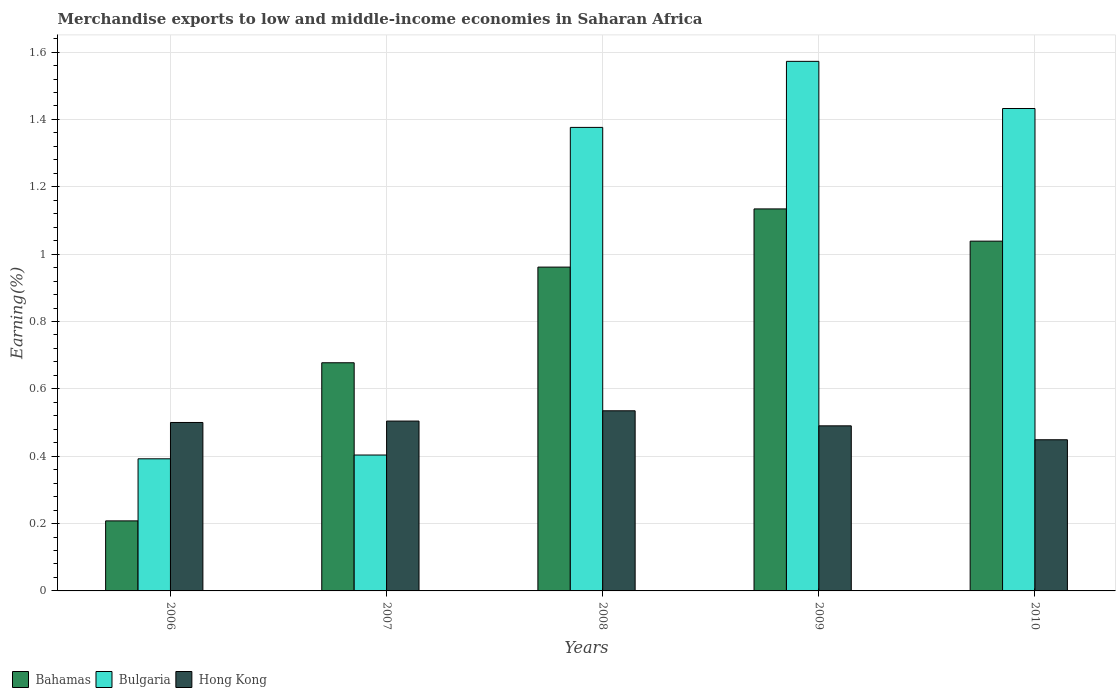Are the number of bars per tick equal to the number of legend labels?
Your answer should be very brief. Yes. Are the number of bars on each tick of the X-axis equal?
Your answer should be compact. Yes. What is the label of the 4th group of bars from the left?
Make the answer very short. 2009. What is the percentage of amount earned from merchandise exports in Hong Kong in 2008?
Keep it short and to the point. 0.53. Across all years, what is the maximum percentage of amount earned from merchandise exports in Hong Kong?
Your answer should be compact. 0.53. Across all years, what is the minimum percentage of amount earned from merchandise exports in Bulgaria?
Provide a short and direct response. 0.39. What is the total percentage of amount earned from merchandise exports in Bulgaria in the graph?
Offer a terse response. 5.18. What is the difference between the percentage of amount earned from merchandise exports in Bahamas in 2006 and that in 2009?
Keep it short and to the point. -0.93. What is the difference between the percentage of amount earned from merchandise exports in Hong Kong in 2007 and the percentage of amount earned from merchandise exports in Bulgaria in 2009?
Make the answer very short. -1.07. What is the average percentage of amount earned from merchandise exports in Bahamas per year?
Your answer should be very brief. 0.8. In the year 2008, what is the difference between the percentage of amount earned from merchandise exports in Bulgaria and percentage of amount earned from merchandise exports in Bahamas?
Keep it short and to the point. 0.41. In how many years, is the percentage of amount earned from merchandise exports in Bahamas greater than 0.56 %?
Your answer should be compact. 4. What is the ratio of the percentage of amount earned from merchandise exports in Bulgaria in 2007 to that in 2010?
Provide a succinct answer. 0.28. Is the difference between the percentage of amount earned from merchandise exports in Bulgaria in 2007 and 2008 greater than the difference between the percentage of amount earned from merchandise exports in Bahamas in 2007 and 2008?
Offer a terse response. No. What is the difference between the highest and the second highest percentage of amount earned from merchandise exports in Bahamas?
Offer a terse response. 0.1. What is the difference between the highest and the lowest percentage of amount earned from merchandise exports in Hong Kong?
Your response must be concise. 0.09. In how many years, is the percentage of amount earned from merchandise exports in Bahamas greater than the average percentage of amount earned from merchandise exports in Bahamas taken over all years?
Your response must be concise. 3. What does the 3rd bar from the left in 2008 represents?
Your response must be concise. Hong Kong. What does the 1st bar from the right in 2006 represents?
Provide a short and direct response. Hong Kong. How many bars are there?
Your response must be concise. 15. Are all the bars in the graph horizontal?
Keep it short and to the point. No. How many years are there in the graph?
Your response must be concise. 5. Are the values on the major ticks of Y-axis written in scientific E-notation?
Provide a short and direct response. No. Does the graph contain any zero values?
Provide a succinct answer. No. Where does the legend appear in the graph?
Ensure brevity in your answer.  Bottom left. How are the legend labels stacked?
Offer a terse response. Horizontal. What is the title of the graph?
Your answer should be compact. Merchandise exports to low and middle-income economies in Saharan Africa. Does "Tanzania" appear as one of the legend labels in the graph?
Provide a succinct answer. No. What is the label or title of the Y-axis?
Give a very brief answer. Earning(%). What is the Earning(%) of Bahamas in 2006?
Ensure brevity in your answer.  0.21. What is the Earning(%) of Bulgaria in 2006?
Ensure brevity in your answer.  0.39. What is the Earning(%) of Hong Kong in 2006?
Offer a very short reply. 0.5. What is the Earning(%) of Bahamas in 2007?
Your answer should be compact. 0.68. What is the Earning(%) of Bulgaria in 2007?
Provide a short and direct response. 0.4. What is the Earning(%) of Hong Kong in 2007?
Make the answer very short. 0.5. What is the Earning(%) in Bahamas in 2008?
Make the answer very short. 0.96. What is the Earning(%) in Bulgaria in 2008?
Your answer should be very brief. 1.38. What is the Earning(%) in Hong Kong in 2008?
Make the answer very short. 0.53. What is the Earning(%) of Bahamas in 2009?
Your answer should be very brief. 1.13. What is the Earning(%) of Bulgaria in 2009?
Offer a very short reply. 1.57. What is the Earning(%) of Hong Kong in 2009?
Your answer should be very brief. 0.49. What is the Earning(%) of Bahamas in 2010?
Provide a succinct answer. 1.04. What is the Earning(%) in Bulgaria in 2010?
Give a very brief answer. 1.43. What is the Earning(%) in Hong Kong in 2010?
Make the answer very short. 0.45. Across all years, what is the maximum Earning(%) in Bahamas?
Provide a succinct answer. 1.13. Across all years, what is the maximum Earning(%) of Bulgaria?
Your response must be concise. 1.57. Across all years, what is the maximum Earning(%) of Hong Kong?
Offer a very short reply. 0.53. Across all years, what is the minimum Earning(%) in Bahamas?
Your answer should be very brief. 0.21. Across all years, what is the minimum Earning(%) of Bulgaria?
Provide a short and direct response. 0.39. Across all years, what is the minimum Earning(%) in Hong Kong?
Your answer should be compact. 0.45. What is the total Earning(%) of Bahamas in the graph?
Offer a very short reply. 4.02. What is the total Earning(%) of Bulgaria in the graph?
Give a very brief answer. 5.18. What is the total Earning(%) in Hong Kong in the graph?
Provide a short and direct response. 2.48. What is the difference between the Earning(%) of Bahamas in 2006 and that in 2007?
Offer a terse response. -0.47. What is the difference between the Earning(%) of Bulgaria in 2006 and that in 2007?
Ensure brevity in your answer.  -0.01. What is the difference between the Earning(%) of Hong Kong in 2006 and that in 2007?
Give a very brief answer. -0. What is the difference between the Earning(%) of Bahamas in 2006 and that in 2008?
Your answer should be very brief. -0.75. What is the difference between the Earning(%) in Bulgaria in 2006 and that in 2008?
Provide a succinct answer. -0.98. What is the difference between the Earning(%) in Hong Kong in 2006 and that in 2008?
Offer a very short reply. -0.03. What is the difference between the Earning(%) in Bahamas in 2006 and that in 2009?
Give a very brief answer. -0.93. What is the difference between the Earning(%) of Bulgaria in 2006 and that in 2009?
Give a very brief answer. -1.18. What is the difference between the Earning(%) of Hong Kong in 2006 and that in 2009?
Your response must be concise. 0.01. What is the difference between the Earning(%) of Bahamas in 2006 and that in 2010?
Offer a very short reply. -0.83. What is the difference between the Earning(%) of Bulgaria in 2006 and that in 2010?
Your answer should be very brief. -1.04. What is the difference between the Earning(%) in Hong Kong in 2006 and that in 2010?
Make the answer very short. 0.05. What is the difference between the Earning(%) of Bahamas in 2007 and that in 2008?
Your response must be concise. -0.28. What is the difference between the Earning(%) of Bulgaria in 2007 and that in 2008?
Keep it short and to the point. -0.97. What is the difference between the Earning(%) of Hong Kong in 2007 and that in 2008?
Provide a succinct answer. -0.03. What is the difference between the Earning(%) in Bahamas in 2007 and that in 2009?
Ensure brevity in your answer.  -0.46. What is the difference between the Earning(%) of Bulgaria in 2007 and that in 2009?
Give a very brief answer. -1.17. What is the difference between the Earning(%) in Hong Kong in 2007 and that in 2009?
Give a very brief answer. 0.01. What is the difference between the Earning(%) in Bahamas in 2007 and that in 2010?
Ensure brevity in your answer.  -0.36. What is the difference between the Earning(%) of Bulgaria in 2007 and that in 2010?
Your answer should be compact. -1.03. What is the difference between the Earning(%) of Hong Kong in 2007 and that in 2010?
Your answer should be very brief. 0.06. What is the difference between the Earning(%) in Bahamas in 2008 and that in 2009?
Provide a short and direct response. -0.17. What is the difference between the Earning(%) in Bulgaria in 2008 and that in 2009?
Provide a short and direct response. -0.2. What is the difference between the Earning(%) in Hong Kong in 2008 and that in 2009?
Offer a terse response. 0.04. What is the difference between the Earning(%) in Bahamas in 2008 and that in 2010?
Your response must be concise. -0.08. What is the difference between the Earning(%) of Bulgaria in 2008 and that in 2010?
Keep it short and to the point. -0.06. What is the difference between the Earning(%) in Hong Kong in 2008 and that in 2010?
Your answer should be very brief. 0.09. What is the difference between the Earning(%) in Bahamas in 2009 and that in 2010?
Give a very brief answer. 0.1. What is the difference between the Earning(%) of Bulgaria in 2009 and that in 2010?
Keep it short and to the point. 0.14. What is the difference between the Earning(%) in Hong Kong in 2009 and that in 2010?
Make the answer very short. 0.04. What is the difference between the Earning(%) of Bahamas in 2006 and the Earning(%) of Bulgaria in 2007?
Give a very brief answer. -0.2. What is the difference between the Earning(%) of Bahamas in 2006 and the Earning(%) of Hong Kong in 2007?
Give a very brief answer. -0.3. What is the difference between the Earning(%) of Bulgaria in 2006 and the Earning(%) of Hong Kong in 2007?
Your answer should be very brief. -0.11. What is the difference between the Earning(%) of Bahamas in 2006 and the Earning(%) of Bulgaria in 2008?
Your answer should be compact. -1.17. What is the difference between the Earning(%) in Bahamas in 2006 and the Earning(%) in Hong Kong in 2008?
Offer a very short reply. -0.33. What is the difference between the Earning(%) of Bulgaria in 2006 and the Earning(%) of Hong Kong in 2008?
Your response must be concise. -0.14. What is the difference between the Earning(%) in Bahamas in 2006 and the Earning(%) in Bulgaria in 2009?
Give a very brief answer. -1.36. What is the difference between the Earning(%) of Bahamas in 2006 and the Earning(%) of Hong Kong in 2009?
Your answer should be very brief. -0.28. What is the difference between the Earning(%) in Bulgaria in 2006 and the Earning(%) in Hong Kong in 2009?
Your answer should be compact. -0.1. What is the difference between the Earning(%) in Bahamas in 2006 and the Earning(%) in Bulgaria in 2010?
Your answer should be very brief. -1.22. What is the difference between the Earning(%) of Bahamas in 2006 and the Earning(%) of Hong Kong in 2010?
Ensure brevity in your answer.  -0.24. What is the difference between the Earning(%) of Bulgaria in 2006 and the Earning(%) of Hong Kong in 2010?
Ensure brevity in your answer.  -0.06. What is the difference between the Earning(%) of Bahamas in 2007 and the Earning(%) of Bulgaria in 2008?
Your answer should be compact. -0.7. What is the difference between the Earning(%) in Bahamas in 2007 and the Earning(%) in Hong Kong in 2008?
Offer a very short reply. 0.14. What is the difference between the Earning(%) in Bulgaria in 2007 and the Earning(%) in Hong Kong in 2008?
Offer a terse response. -0.13. What is the difference between the Earning(%) of Bahamas in 2007 and the Earning(%) of Bulgaria in 2009?
Give a very brief answer. -0.9. What is the difference between the Earning(%) of Bahamas in 2007 and the Earning(%) of Hong Kong in 2009?
Your answer should be very brief. 0.19. What is the difference between the Earning(%) in Bulgaria in 2007 and the Earning(%) in Hong Kong in 2009?
Keep it short and to the point. -0.09. What is the difference between the Earning(%) in Bahamas in 2007 and the Earning(%) in Bulgaria in 2010?
Provide a succinct answer. -0.76. What is the difference between the Earning(%) in Bahamas in 2007 and the Earning(%) in Hong Kong in 2010?
Ensure brevity in your answer.  0.23. What is the difference between the Earning(%) of Bulgaria in 2007 and the Earning(%) of Hong Kong in 2010?
Your answer should be compact. -0.05. What is the difference between the Earning(%) in Bahamas in 2008 and the Earning(%) in Bulgaria in 2009?
Provide a short and direct response. -0.61. What is the difference between the Earning(%) in Bahamas in 2008 and the Earning(%) in Hong Kong in 2009?
Provide a succinct answer. 0.47. What is the difference between the Earning(%) in Bulgaria in 2008 and the Earning(%) in Hong Kong in 2009?
Keep it short and to the point. 0.89. What is the difference between the Earning(%) in Bahamas in 2008 and the Earning(%) in Bulgaria in 2010?
Your answer should be compact. -0.47. What is the difference between the Earning(%) in Bahamas in 2008 and the Earning(%) in Hong Kong in 2010?
Keep it short and to the point. 0.51. What is the difference between the Earning(%) in Bulgaria in 2008 and the Earning(%) in Hong Kong in 2010?
Provide a short and direct response. 0.93. What is the difference between the Earning(%) in Bahamas in 2009 and the Earning(%) in Bulgaria in 2010?
Ensure brevity in your answer.  -0.3. What is the difference between the Earning(%) in Bahamas in 2009 and the Earning(%) in Hong Kong in 2010?
Keep it short and to the point. 0.69. What is the difference between the Earning(%) of Bulgaria in 2009 and the Earning(%) of Hong Kong in 2010?
Give a very brief answer. 1.12. What is the average Earning(%) of Bahamas per year?
Your response must be concise. 0.8. What is the average Earning(%) of Bulgaria per year?
Offer a very short reply. 1.04. What is the average Earning(%) in Hong Kong per year?
Ensure brevity in your answer.  0.5. In the year 2006, what is the difference between the Earning(%) of Bahamas and Earning(%) of Bulgaria?
Provide a succinct answer. -0.18. In the year 2006, what is the difference between the Earning(%) in Bahamas and Earning(%) in Hong Kong?
Keep it short and to the point. -0.29. In the year 2006, what is the difference between the Earning(%) in Bulgaria and Earning(%) in Hong Kong?
Your answer should be compact. -0.11. In the year 2007, what is the difference between the Earning(%) in Bahamas and Earning(%) in Bulgaria?
Keep it short and to the point. 0.27. In the year 2007, what is the difference between the Earning(%) in Bahamas and Earning(%) in Hong Kong?
Your answer should be compact. 0.17. In the year 2007, what is the difference between the Earning(%) of Bulgaria and Earning(%) of Hong Kong?
Your answer should be compact. -0.1. In the year 2008, what is the difference between the Earning(%) in Bahamas and Earning(%) in Bulgaria?
Offer a terse response. -0.41. In the year 2008, what is the difference between the Earning(%) in Bahamas and Earning(%) in Hong Kong?
Ensure brevity in your answer.  0.43. In the year 2008, what is the difference between the Earning(%) in Bulgaria and Earning(%) in Hong Kong?
Your response must be concise. 0.84. In the year 2009, what is the difference between the Earning(%) in Bahamas and Earning(%) in Bulgaria?
Ensure brevity in your answer.  -0.44. In the year 2009, what is the difference between the Earning(%) of Bahamas and Earning(%) of Hong Kong?
Give a very brief answer. 0.64. In the year 2009, what is the difference between the Earning(%) of Bulgaria and Earning(%) of Hong Kong?
Offer a very short reply. 1.08. In the year 2010, what is the difference between the Earning(%) in Bahamas and Earning(%) in Bulgaria?
Your response must be concise. -0.39. In the year 2010, what is the difference between the Earning(%) in Bahamas and Earning(%) in Hong Kong?
Provide a short and direct response. 0.59. In the year 2010, what is the difference between the Earning(%) in Bulgaria and Earning(%) in Hong Kong?
Ensure brevity in your answer.  0.98. What is the ratio of the Earning(%) of Bahamas in 2006 to that in 2007?
Make the answer very short. 0.31. What is the ratio of the Earning(%) of Bulgaria in 2006 to that in 2007?
Your answer should be very brief. 0.97. What is the ratio of the Earning(%) of Bahamas in 2006 to that in 2008?
Offer a very short reply. 0.22. What is the ratio of the Earning(%) in Bulgaria in 2006 to that in 2008?
Keep it short and to the point. 0.28. What is the ratio of the Earning(%) in Hong Kong in 2006 to that in 2008?
Your answer should be compact. 0.94. What is the ratio of the Earning(%) of Bahamas in 2006 to that in 2009?
Offer a very short reply. 0.18. What is the ratio of the Earning(%) of Bulgaria in 2006 to that in 2009?
Offer a terse response. 0.25. What is the ratio of the Earning(%) of Hong Kong in 2006 to that in 2009?
Provide a succinct answer. 1.02. What is the ratio of the Earning(%) of Bahamas in 2006 to that in 2010?
Provide a succinct answer. 0.2. What is the ratio of the Earning(%) of Bulgaria in 2006 to that in 2010?
Provide a short and direct response. 0.27. What is the ratio of the Earning(%) in Hong Kong in 2006 to that in 2010?
Provide a short and direct response. 1.11. What is the ratio of the Earning(%) of Bahamas in 2007 to that in 2008?
Your answer should be very brief. 0.7. What is the ratio of the Earning(%) in Bulgaria in 2007 to that in 2008?
Ensure brevity in your answer.  0.29. What is the ratio of the Earning(%) of Hong Kong in 2007 to that in 2008?
Your answer should be compact. 0.94. What is the ratio of the Earning(%) of Bahamas in 2007 to that in 2009?
Your response must be concise. 0.6. What is the ratio of the Earning(%) in Bulgaria in 2007 to that in 2009?
Make the answer very short. 0.26. What is the ratio of the Earning(%) in Hong Kong in 2007 to that in 2009?
Your answer should be compact. 1.03. What is the ratio of the Earning(%) of Bahamas in 2007 to that in 2010?
Ensure brevity in your answer.  0.65. What is the ratio of the Earning(%) of Bulgaria in 2007 to that in 2010?
Your response must be concise. 0.28. What is the ratio of the Earning(%) in Hong Kong in 2007 to that in 2010?
Give a very brief answer. 1.12. What is the ratio of the Earning(%) of Bahamas in 2008 to that in 2009?
Your response must be concise. 0.85. What is the ratio of the Earning(%) in Bulgaria in 2008 to that in 2009?
Provide a short and direct response. 0.88. What is the ratio of the Earning(%) in Hong Kong in 2008 to that in 2009?
Offer a terse response. 1.09. What is the ratio of the Earning(%) of Bahamas in 2008 to that in 2010?
Make the answer very short. 0.93. What is the ratio of the Earning(%) of Bulgaria in 2008 to that in 2010?
Keep it short and to the point. 0.96. What is the ratio of the Earning(%) of Hong Kong in 2008 to that in 2010?
Make the answer very short. 1.19. What is the ratio of the Earning(%) in Bahamas in 2009 to that in 2010?
Provide a short and direct response. 1.09. What is the ratio of the Earning(%) in Bulgaria in 2009 to that in 2010?
Offer a terse response. 1.1. What is the ratio of the Earning(%) in Hong Kong in 2009 to that in 2010?
Provide a short and direct response. 1.09. What is the difference between the highest and the second highest Earning(%) in Bahamas?
Offer a very short reply. 0.1. What is the difference between the highest and the second highest Earning(%) of Bulgaria?
Keep it short and to the point. 0.14. What is the difference between the highest and the second highest Earning(%) of Hong Kong?
Give a very brief answer. 0.03. What is the difference between the highest and the lowest Earning(%) of Bahamas?
Provide a short and direct response. 0.93. What is the difference between the highest and the lowest Earning(%) in Bulgaria?
Keep it short and to the point. 1.18. What is the difference between the highest and the lowest Earning(%) of Hong Kong?
Offer a very short reply. 0.09. 